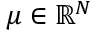Convert formula to latex. <formula><loc_0><loc_0><loc_500><loc_500>\mu \in { \mathbb { R } } ^ { N }</formula> 